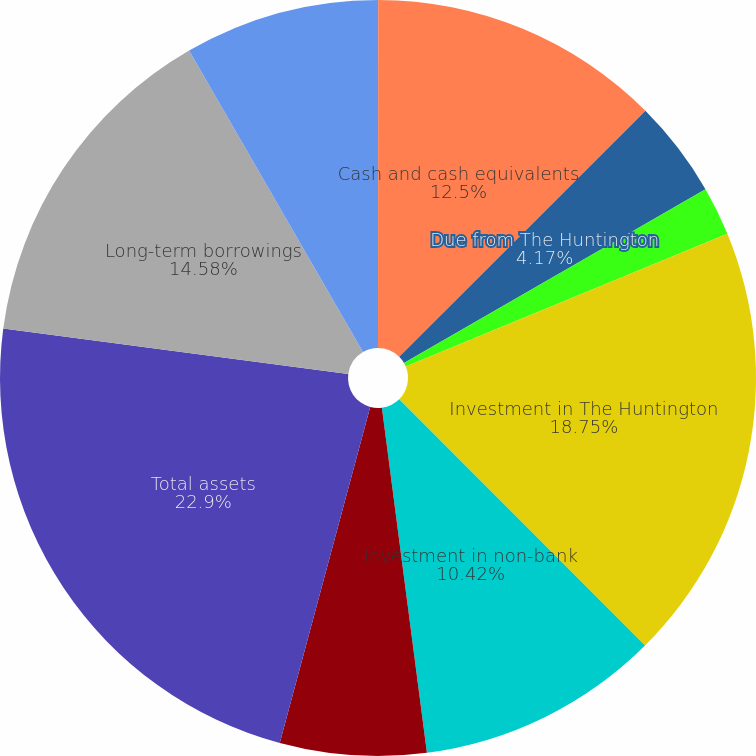Convert chart to OTSL. <chart><loc_0><loc_0><loc_500><loc_500><pie_chart><fcel>(dollar amounts in thousands)<fcel>Cash and cash equivalents<fcel>Due from The Huntington<fcel>Due from non-bank subsidiaries<fcel>Investment in The Huntington<fcel>Investment in non-bank<fcel>Accrued interest receivable<fcel>Total assets<fcel>Long-term borrowings<fcel>Dividends payable accrued<nl><fcel>0.01%<fcel>12.5%<fcel>4.17%<fcel>2.09%<fcel>18.75%<fcel>10.42%<fcel>6.25%<fcel>22.91%<fcel>14.58%<fcel>8.33%<nl></chart> 